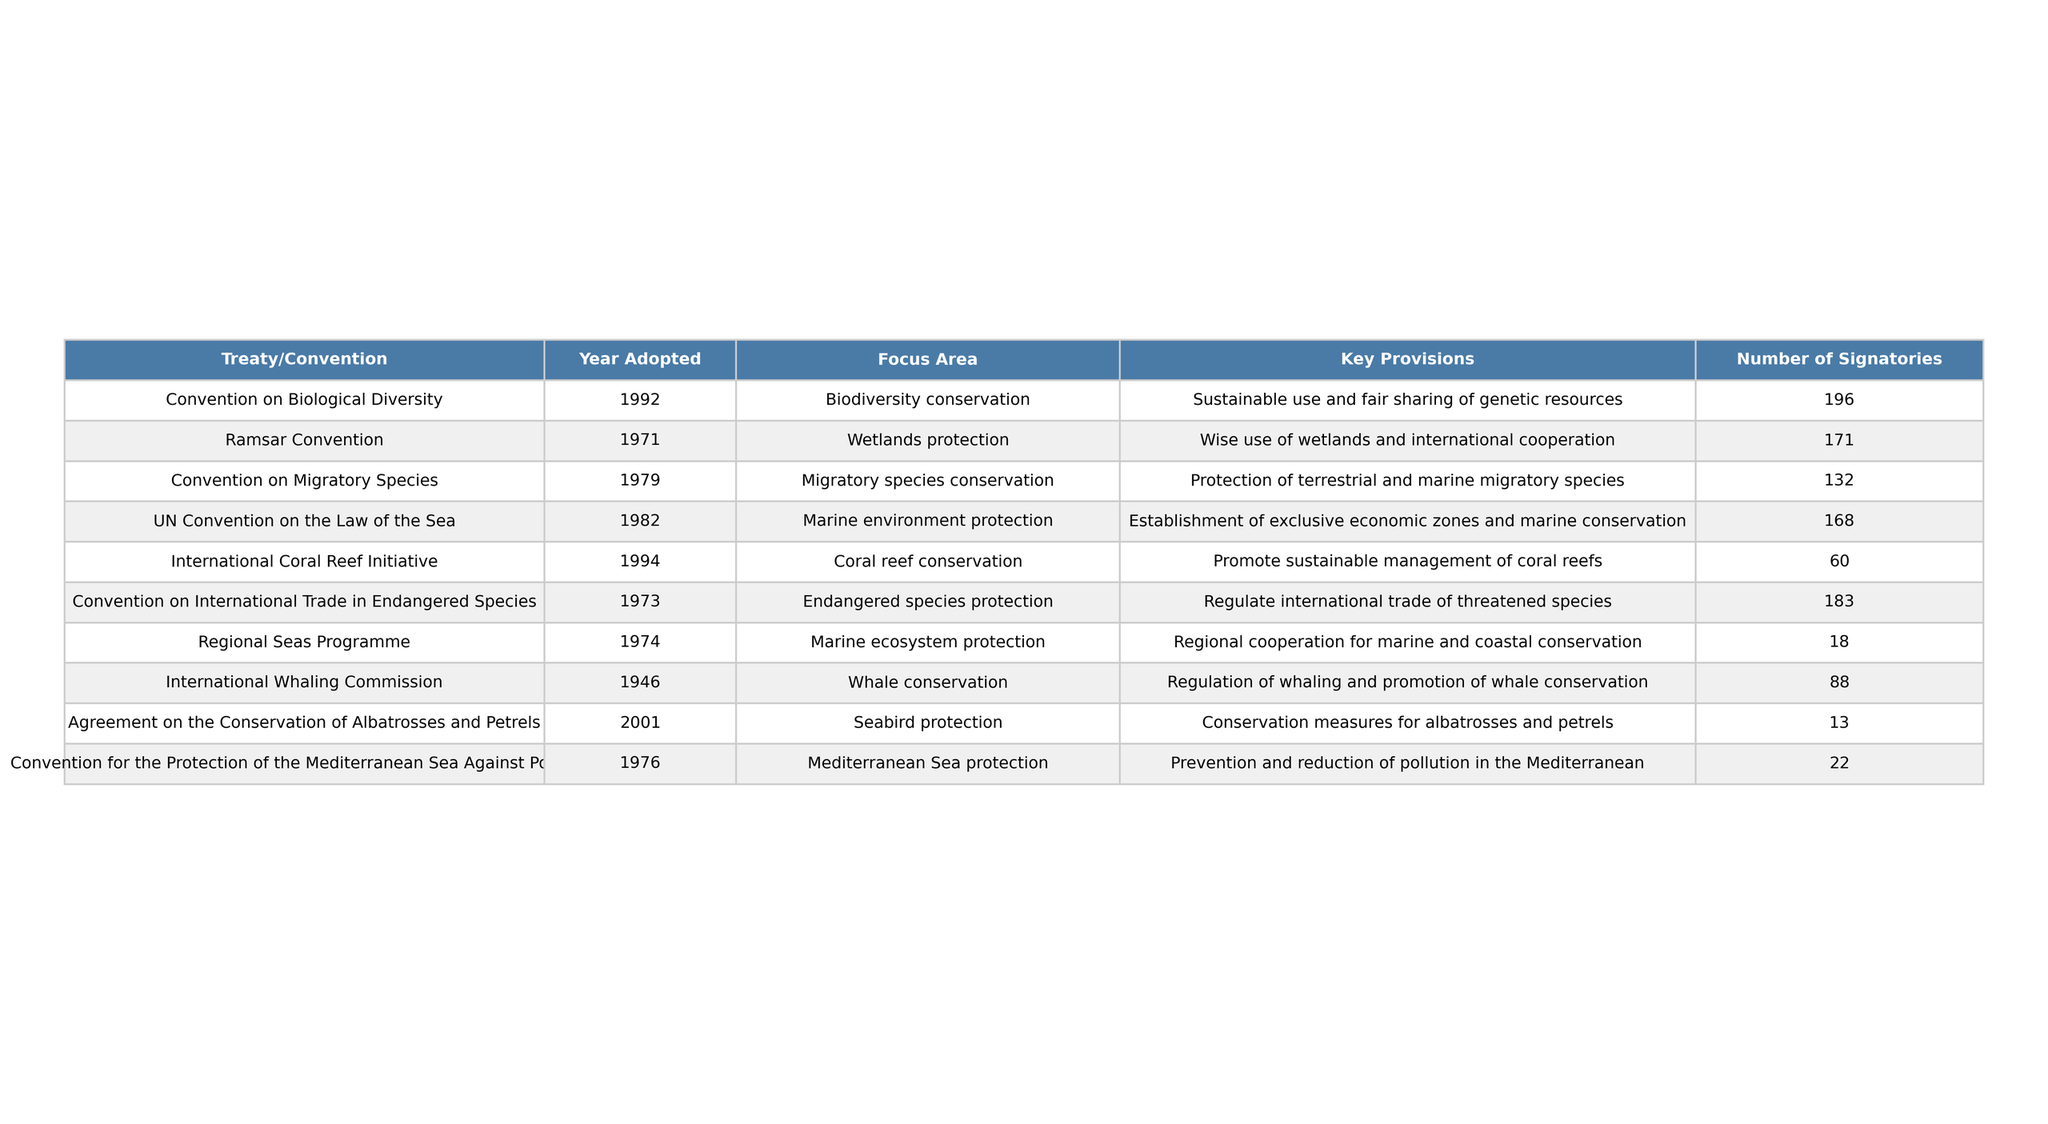What year was the Convention on Biological Diversity adopted? The table shows that the Convention on Biological Diversity was adopted in 1992.
Answer: 1992 How many signatories are there for the Ramsar Convention? According to the table, the Ramsar Convention has 171 signatories listed.
Answer: 171 Which convention focuses on endangered species protection? The table states that the Convention on International Trade in Endangered Species focuses on endangered species protection.
Answer: Convention on International Trade in Endangered Species What is the key provision of the UN Convention on the Law of the Sea? The table indicates that the key provision of the UN Convention on the Law of the Sea is the establishment of exclusive economic zones and marine conservation.
Answer: Establishment of exclusive economic zones and marine conservation What is the average number of signatories for all treaties listed? To find the average, sum all the signatories (196 + 171 + 132 + 168 + 60 + 183 + 18 + 88 + 13 + 22 = 1,063) and divide by the number of treaties (10): 1,063 / 10 = 106.3.
Answer: 106.3 How many conventions focus on marine ecosystem protection? The table shows two conventions focusing on marine ecosystem protection: the UN Convention on the Law of the Sea and the Regional Seas Programme.
Answer: 2 Is the International Coral Reef Initiative the oldest treaty listed? The table shows that the International Coral Reef Initiative was adopted in 1994, while the oldest treaty listed is the International Whaling Commission, adopted in 1946. Thus, the statement is false.
Answer: No Which convention has the fewest signatories? The table indicates that the Agreement on the Conservation of Albatrosses and Petrels has the fewest signatories, with only 13.
Answer: Agreement on the Conservation of Albatrosses and Petrels How many treaties focus specifically on coastal and marine environments? The table lists four treaties focusing specifically on coastal and marine environments: the Ramsar Convention, UN Convention on the Law of the Sea, Regional Seas Programme, and the International Coral Reef Initiative.
Answer: 4 What is the difference in the number of signatories between the Convention on Biological Diversity and the Convention on Migratory Species? The difference in signatories is calculated by subtracting the number of signatories for the Convention on Migratory Species (132) from the Convention on Biological Diversity (196): 196 - 132 = 64.
Answer: 64 